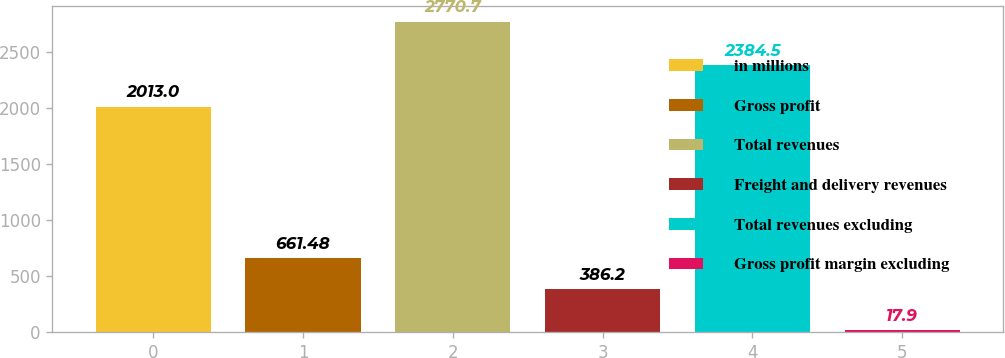Convert chart. <chart><loc_0><loc_0><loc_500><loc_500><bar_chart><fcel>in millions<fcel>Gross profit<fcel>Total revenues<fcel>Freight and delivery revenues<fcel>Total revenues excluding<fcel>Gross profit margin excluding<nl><fcel>2013<fcel>661.48<fcel>2770.7<fcel>386.2<fcel>2384.5<fcel>17.9<nl></chart> 